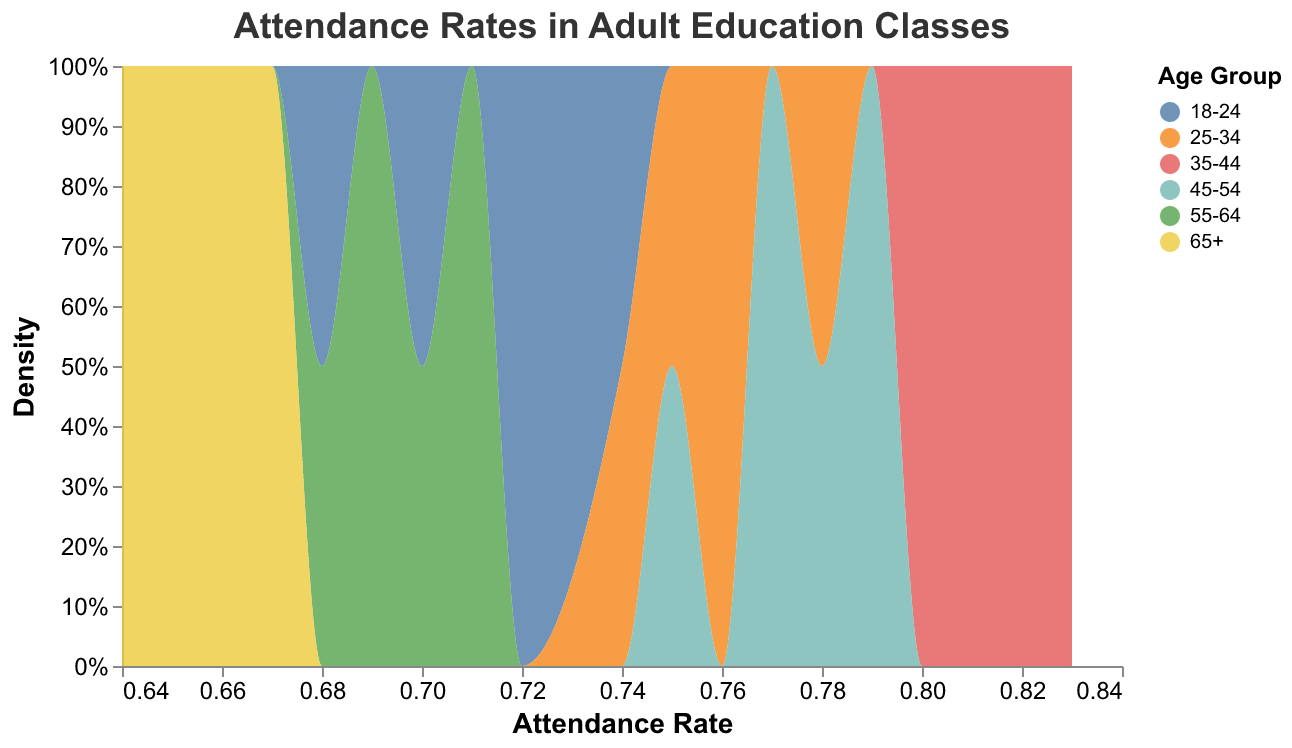What is the title of the plot? The title of the plot is written at the top and it reads "Attendance Rates in Adult Education Classes.”
Answer: Attendance Rates in Adult Education Classes What is the color of the density plot line? The color of the density plot line is green, as indicated by its color on the plot.
Answer: Green Which age group has the highest attendance rate? By looking for the peak value in different color regions, we can see that the 35-44 age group consistently has the highest attendance rates.
Answer: 35-44 Where do the 65+ age groups mainly fall in terms of attendance rate? Observing the density plot for the age group labeled 65+, their attendance rates mainly fall between 0.64 and 0.67
Answer: Between 0.64 and 0.67 Which age group has the most diverse range of attendance rates? By analyzing the spread of the density plot, the 55-64 age group shows a wider horizontal spread indicating more variability in attendance rates.
Answer: 55-64 What is the attendance rate range for the 18-24 age group? Observing the plot, the 18-24 age group's attendance rates range from 0.68 to 0.74
Answer: 0.68 to 0.74 Compare the attendance rates of the 25-34 and 45-54 age groups. The 25-34 age group has attendance rates ranging from 0.74 to 0.78, whereas the 45-54 age group ranges from 0.75 to 0.79.
Answer: The 45-54 age group has slightly higher attendance rates What's the general trend in attendance rates as the age groups increase? From younger to older age groups, the general trend shows fluctuating attendance rates starting high, peaking around mid-age, and then decreasing in older age.
Answer: Fluctuates and then decreases in older age Which age group shows the highest density value in the plot? By observing the peaks in the density plot, the highest-density peak belongs to the 35-44 age group.
Answer: 35-44 